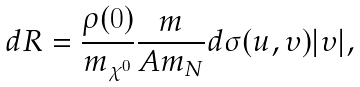<formula> <loc_0><loc_0><loc_500><loc_500>d R = \frac { \rho ( 0 ) } { m _ { \chi ^ { 0 } } } \frac { m } { A m _ { N } } d \sigma ( u , \upsilon ) | { \boldmath \upsilon } | ,</formula> 